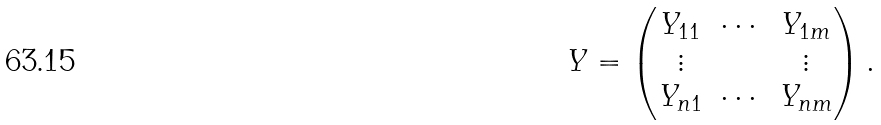Convert formula to latex. <formula><loc_0><loc_0><loc_500><loc_500>Y = \begin{pmatrix} Y _ { 1 1 } & \cdots & Y _ { 1 m } \\ \vdots & & \vdots \\ Y _ { n 1 } & \cdots & Y _ { n m } \end{pmatrix} .</formula> 